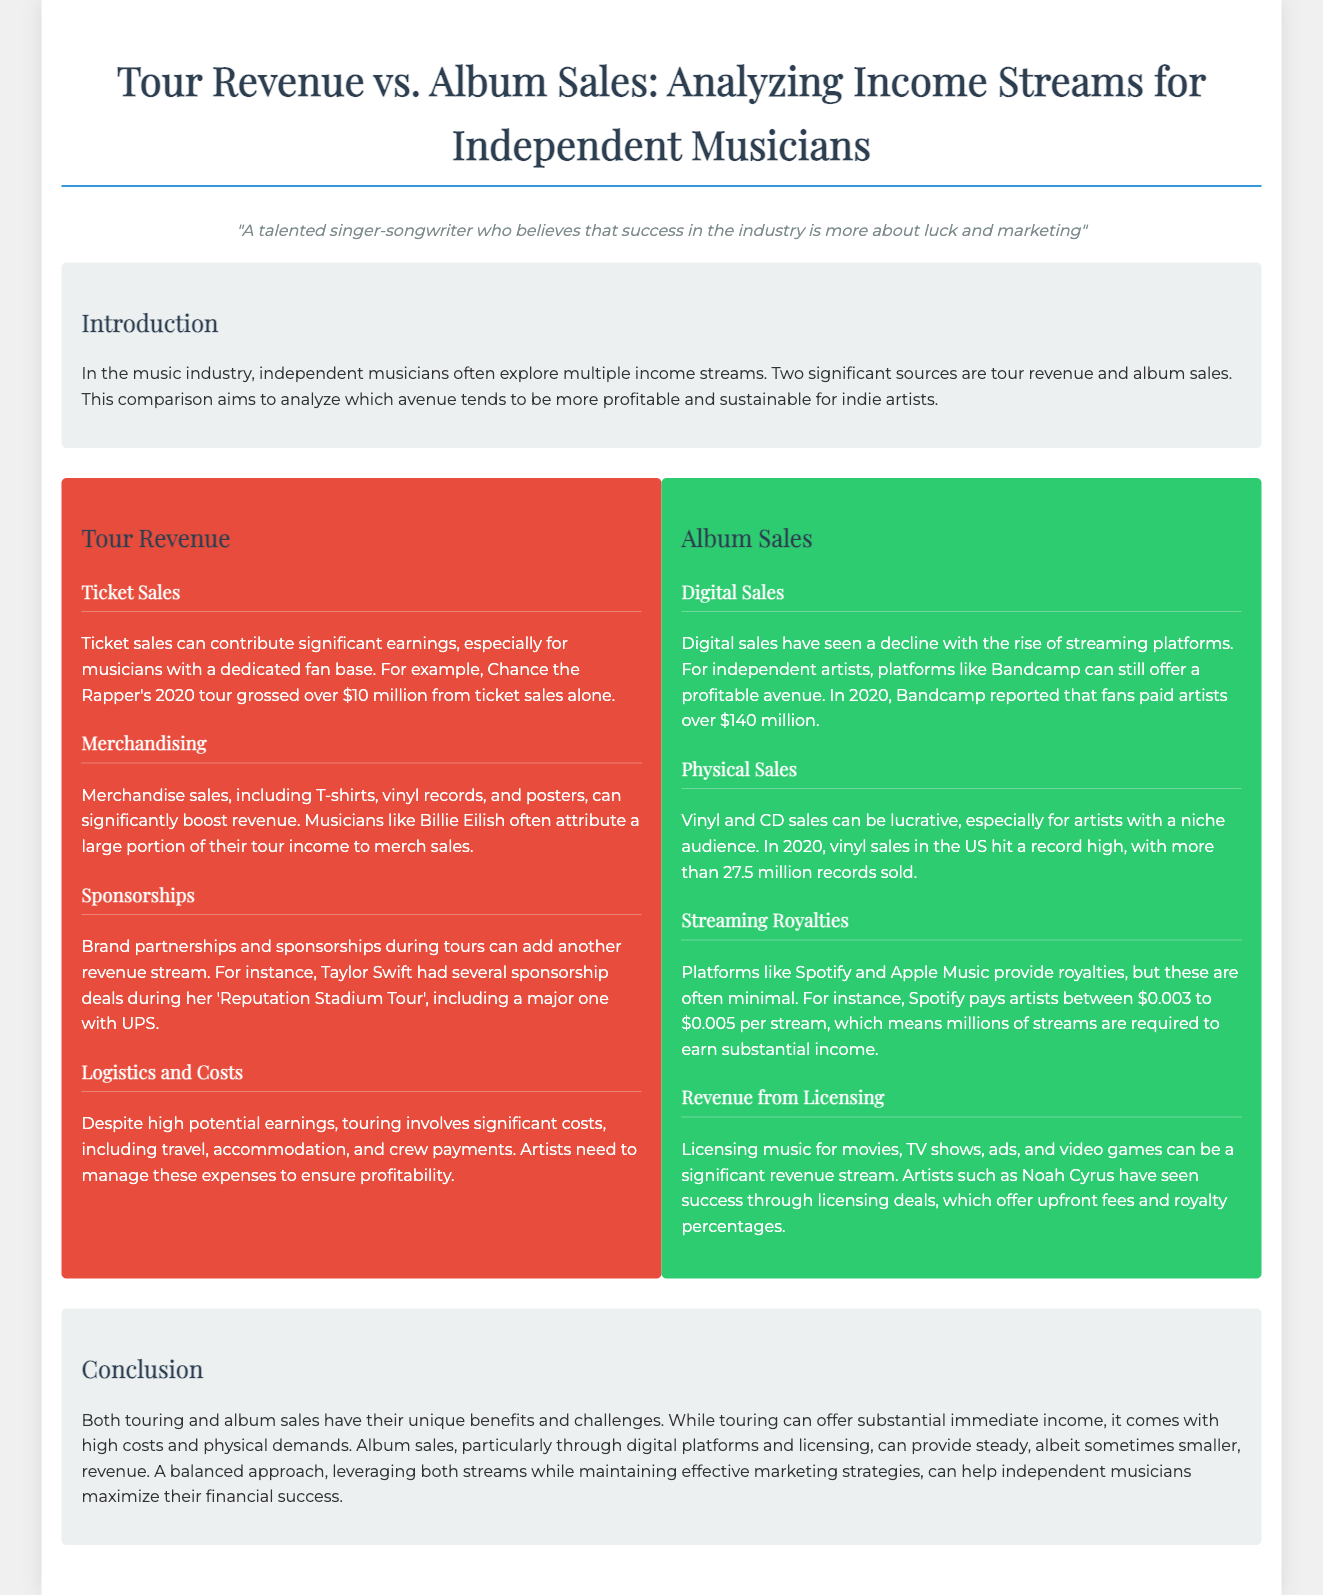what was Chance the Rapper's tour gross from ticket sales? The document states that Chance the Rapper's 2020 tour grossed over $10 million from ticket sales alone.
Answer: over $10 million which artist attributed a large portion of their tour income to merch sales? The document mentions that Billie Eilish often attributes a large portion of her tour income to merch sales.
Answer: Billie Eilish how much did Bandcamp report fans paid artists in 2020? The document claims that in 2020, Bandcamp reported that fans paid artists over $140 million.
Answer: over $140 million what is the range of Spotify's payment per stream? The document indicates that Spotify pays artists between $0.003 to $0.005 per stream.
Answer: $0.003 to $0.005 which artist has seen success through licensing deals? The document refers to Noah Cyrus as an artist who has seen success through licensing deals.
Answer: Noah Cyrus what is a significant drawback of touring mentioned in the document? The document highlights that touring involves significant costs, including travel, accommodation, and crew payments.
Answer: significant costs which type of music sales hit a record high in 2020? The document states that vinyl sales in the US hit a record high in 2020.
Answer: vinyl sales what does the document suggest about a balanced approach for independent musicians? The conclusion emphasizes that a balanced approach, leveraging both streams, can help independent musicians maximize their financial success.
Answer: maximize financial success 